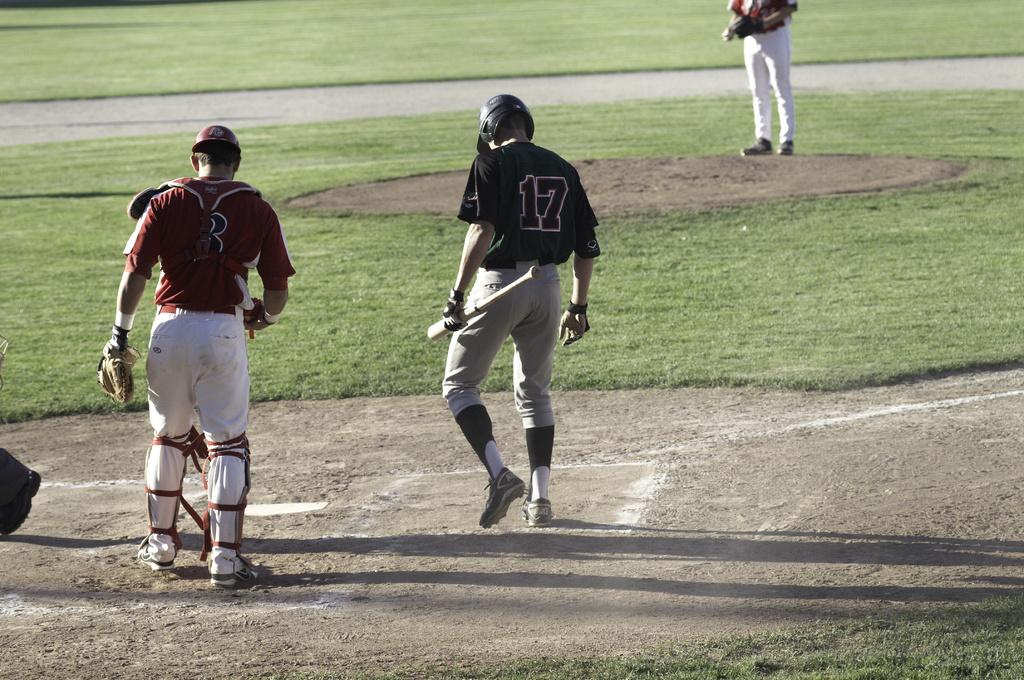What number shirt is the batsman in green wearing?
Offer a terse response. 17. What number is the man in the red jersey wearing?
Offer a terse response. 3. 